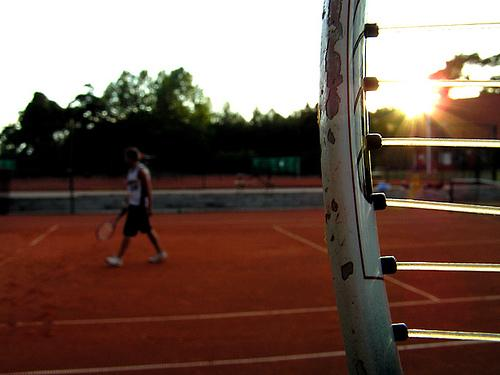How many tennis rackets are in the image? One. Identify the primary activity happening in the image and describe the person involved. A tennis player is playing on the court, holding a racket in their right hand, wearing a white tank top, black shorts, and white sneakers. Describe the sun's position in the image. The sun is visible in the sky, surrounded by sun rays, shining through the trees. Describe the setting where the tennis player is playing. The tennis player is playing on a red tennis court, surrounded by a concrete wall, with green trees in the background and a clear sky. What is the color of the tennis court, and do the white lines appear? The tennis court is red with white boundary lines. Mention three key features of the tennis player's attire. White tank top, black shorts, and white sneakers. What color are the sneakers on the player's feet? White. What is the weather like in the image? Sunny, with clear sky. List five objects you can see in this image. Tennis racket, tennis player, sun, trees, and red tennis court. What kind of trees can be seen in the background? Green leafy trees. Which hand is the tennis player holding the racket in? Right hand What is happening on this red tennis court? Person is playing tennis What is the state of the pole near the tennis court? Rusty Is the player wearing sandals while playing tennis? The instruction is misleading because the player is wearing sneakers, not sandals. What sport is being played in this image? Tennis What color is the container in the background of the image? Green What is the primary color of the tennis court? Red What is the tennis player wearing on his feet? White sneakers What object is connecting the metal pole to the tennis court? Strings What kind of top is the tennis player wearing? White tank top What is the color of the tennis player's shorts? Black What object is attached to the metal pole? Four plastic posts Can you spot the moon in the sky above the trees? The instruction is misleading because the sun is mentioned in the image annotations, not the moon. Can you see a transparent tennis racket held by the player? The instruction is misleading because the tennis racket is not transparent; it has a specified color and shape. How many boundary lines are there on the tennis court? Four Are there purple trees behind the tennis court? The instruction is misleading because the trees mentioned in the annotations are described as green leafy trees, not purple. Which direction is the tennis player walking? To the left Describe the image with emphasis on the weather and trees in the background. A sunny day casts its warmth on a tennis court, with green trees blanketing the backdrop, standing tall under a clear sky. What object is near the red tennis court and appears rusted? Pole Identify the object hidden within the trees. Sun Is there a swimming pool near the tennis court? The instruction is misleading because there is no mention of a swimming pool in any of the image annotations. Is the player wearing a blue shirt on the tennis court? The instruction is misleading because the player is actually wearing a white tank top, not a blue shirt. Describe the scene in a poetic manner. A tennis player gracefully strides left, wielding a racket under sun rays that sneak through leafy green trees beyond the red court's bounds. 